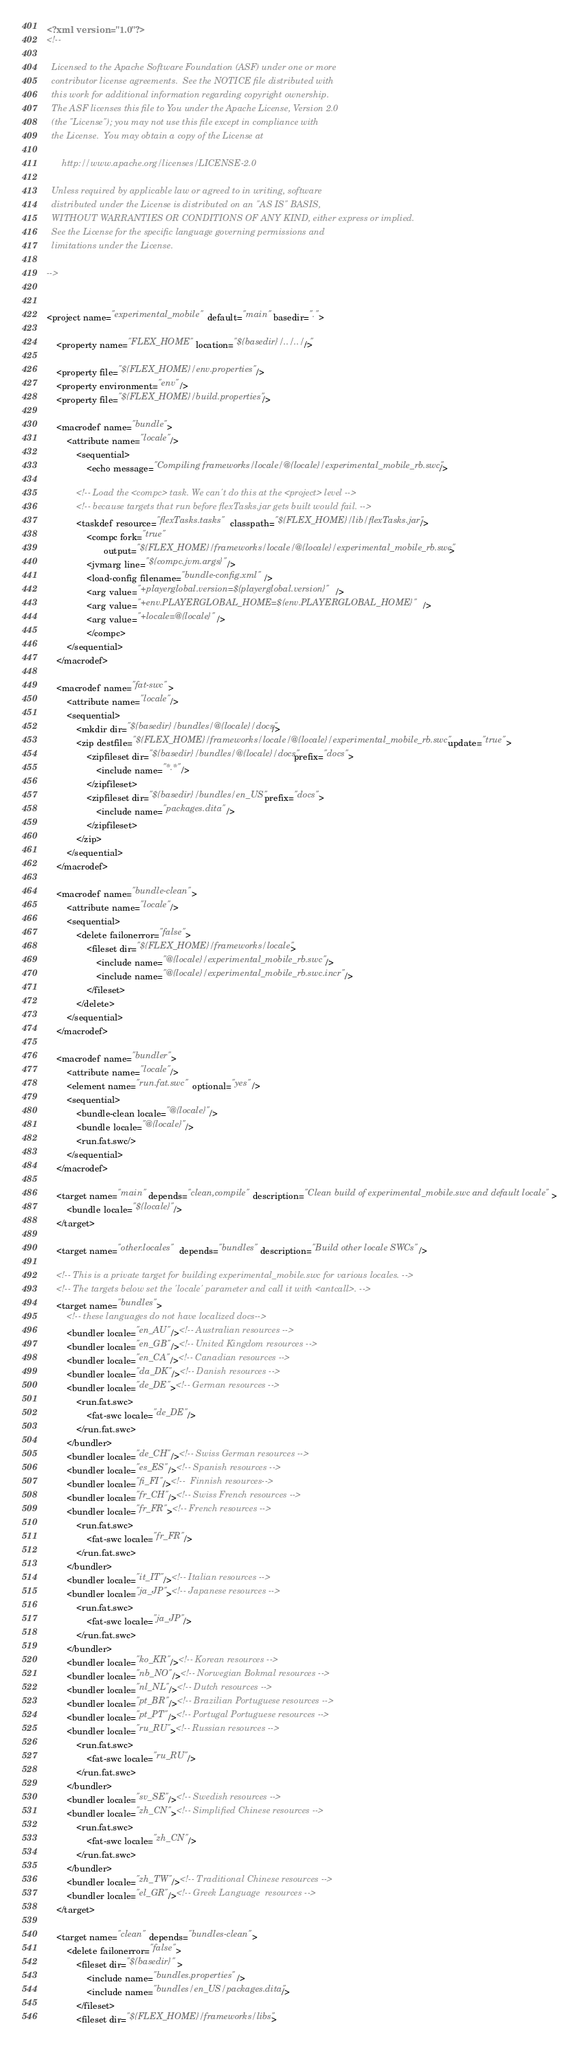<code> <loc_0><loc_0><loc_500><loc_500><_XML_><?xml version="1.0"?>
<!--

  Licensed to the Apache Software Foundation (ASF) under one or more
  contributor license agreements.  See the NOTICE file distributed with
  this work for additional information regarding copyright ownership.
  The ASF licenses this file to You under the Apache License, Version 2.0
  (the "License"); you may not use this file except in compliance with
  the License.  You may obtain a copy of the License at

      http://www.apache.org/licenses/LICENSE-2.0

  Unless required by applicable law or agreed to in writing, software
  distributed under the License is distributed on an "AS IS" BASIS,
  WITHOUT WARRANTIES OR CONDITIONS OF ANY KIND, either express or implied.
  See the License for the specific language governing permissions and
  limitations under the License.

-->


<project name="experimental_mobile" default="main" basedir=".">

	<property name="FLEX_HOME" location="${basedir}/../../.."/>

    <property file="${FLEX_HOME}/env.properties"/>
    <property environment="env"/>
	<property file="${FLEX_HOME}/build.properties"/>

	<macrodef name="bundle">
		<attribute name="locale"/>
			<sequential>
				<echo message="Compiling frameworks/locale/@{locale}/experimental_mobile_rb.swc"/>

			<!-- Load the <compc> task. We can't do this at the <project> level -->
			<!-- because targets that run before flexTasks.jar gets built would fail. -->
			<taskdef resource="flexTasks.tasks" classpath="${FLEX_HOME}/lib/flexTasks.jar"/>
                <compc fork="true"
                       output="${FLEX_HOME}/frameworks/locale/@{locale}/experimental_mobile_rb.swc">
				<jvmarg line="${compc.jvm.args}"/>
                <load-config filename="bundle-config.xml" />
                <arg value="+playerglobal.version=${playerglobal.version}" />
                <arg value="+env.PLAYERGLOBAL_HOME=${env.PLAYERGLOBAL_HOME}" />
                <arg value="+locale=@{locale}" />
                </compc>
		</sequential>
	</macrodef>

	<macrodef name="fat-swc">
		<attribute name="locale"/>
		<sequential>
			<mkdir dir="${basedir}/bundles/@{locale}/docs" />
			<zip destfile="${FLEX_HOME}/frameworks/locale/@{locale}/experimental_mobile_rb.swc" update="true">
				<zipfileset dir="${basedir}/bundles/@{locale}/docs" prefix="docs">
					<include name="*.*"/>
				</zipfileset>
				<zipfileset dir="${basedir}/bundles/en_US" prefix="docs">
					<include name="packages.dita"/>
				</zipfileset>
			</zip>
		</sequential>
	</macrodef>

	<macrodef name="bundle-clean">
		<attribute name="locale"/>
		<sequential>
			<delete failonerror="false">
				<fileset dir="${FLEX_HOME}/frameworks/locale">
					<include name="@{locale}/experimental_mobile_rb.swc"/>
					<include name="@{locale}/experimental_mobile_rb.swc.incr"/>
				</fileset>
			</delete>
		</sequential>
	</macrodef>

	<macrodef name="bundler">
		<attribute name="locale"/>
		<element name="run.fat.swc" optional="yes"/>
		<sequential>
			<bundle-clean locale="@{locale}"/>
			<bundle locale="@{locale}"/>
			<run.fat.swc/>
		</sequential>
	</macrodef>

	<target name="main" depends="clean,compile" description="Clean build of experimental_mobile.swc and default locale">
		<bundle locale="${locale}"/>
	</target>

	<target name="other.locales" depends="bundles" description="Build other locale SWCs"/>

	<!-- This is a private target for building experimental_mobile.swc for various locales. -->
	<!-- The targets below set the 'locale' parameter and call it with <antcall>. -->
	<target name="bundles">
        <!-- these languages do not have localized docs-->
        <bundler locale="en_AU"/><!-- Australian resources -->
        <bundler locale="en_GB"/><!-- United Kingdom resources -->
        <bundler locale="en_CA"/><!-- Canadian resources -->
        <bundler locale="da_DK"/><!-- Danish resources -->
        <bundler locale="de_DE"><!-- German resources -->
            <run.fat.swc>
                <fat-swc locale="de_DE"/>
            </run.fat.swc>
        </bundler>
        <bundler locale="de_CH"/><!-- Swiss German resources -->
        <bundler locale="es_ES"/><!-- Spanish resources -->
        <bundler locale="fi_FI"/><!--  Finnish resources-->
		<bundler locale="fr_CH"/><!-- Swiss French resources -->
        <bundler locale="fr_FR"><!-- French resources -->
            <run.fat.swc>
                <fat-swc locale="fr_FR"/>
            </run.fat.swc>
        </bundler>
        <bundler locale="it_IT"/><!-- Italian resources -->
        <bundler locale="ja_JP"><!-- Japanese resources -->
            <run.fat.swc>
                <fat-swc locale="ja_JP"/>
            </run.fat.swc>
        </bundler>
        <bundler locale="ko_KR"/><!-- Korean resources -->
        <bundler locale="nb_NO"/><!-- Norwegian Bokmal resources -->
        <bundler locale="nl_NL"/><!-- Dutch resources -->
        <bundler locale="pt_BR"/><!-- Brazilian Portuguese resources -->
        <bundler locale="pt_PT"/><!-- Portugal Portuguese resources -->
        <bundler locale="ru_RU"><!-- Russian resources -->
            <run.fat.swc>
                <fat-swc locale="ru_RU"/>
            </run.fat.swc>
        </bundler>
        <bundler locale="sv_SE"/><!-- Swedish resources -->
        <bundler locale="zh_CN"><!-- Simplified Chinese resources -->
            <run.fat.swc>
                <fat-swc locale="zh_CN"/>
            </run.fat.swc>
        </bundler>
        <bundler locale="zh_TW"/><!-- Traditional Chinese resources -->
        <bundler locale="el_GR"/><!-- Greek Language  resources -->
	</target>

	<target name="clean" depends="bundles-clean">
		<delete failonerror="false">
			<fileset dir="${basedir}" >
				<include name="bundles.properties"/>
			    <include name="bundles/en_US/packages.dita"/>
			</fileset>
			<fileset dir="${FLEX_HOME}/frameworks/libs"></code> 